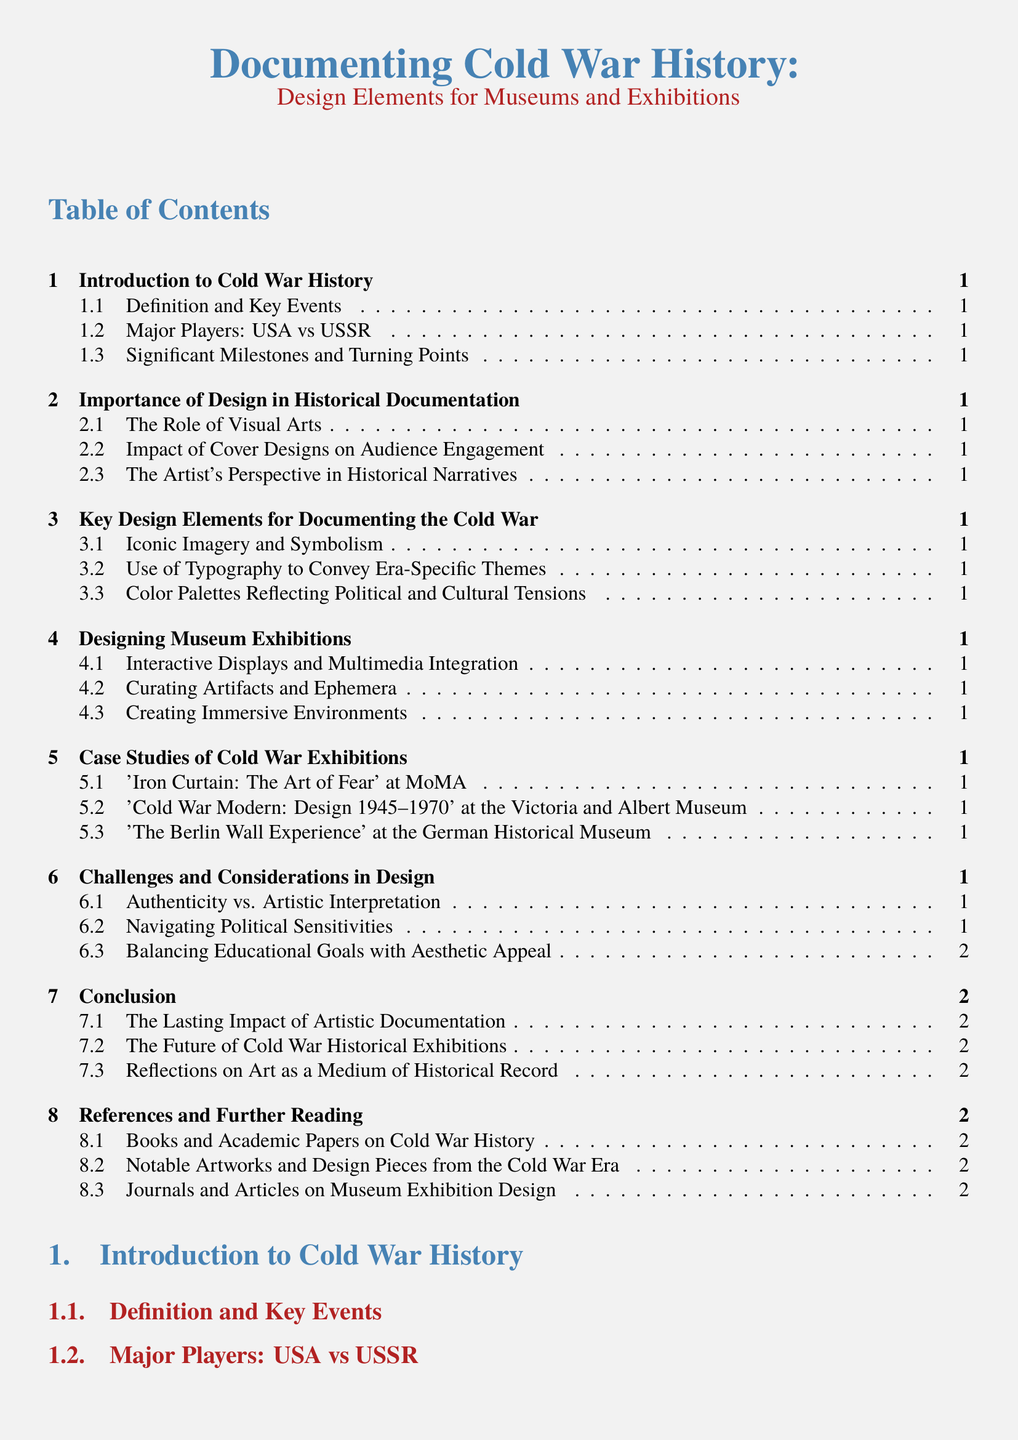What is the title of the document? The title is presented at the beginning of the document, highlighting the focus on Cold War history and design elements for museums and exhibitions.
Answer: Documenting Cold War History: Design Elements for Museums and Exhibitions How many sections are in the document? The total number of sections can be counted in the table of contents, listed under the main headings.
Answer: 7 What are the major players mentioned in Cold War history? The major players in the Cold War are specified in the section about key events and players.
Answer: USA vs USSR Which exhibition is listed first in the case studies section? The first exhibition is noted under case studies, showcasing a specific topic related to Cold War history.
Answer: 'Iron Curtain: The Art of Fear' at MoMA What design aspect is emphasized for audience engagement? The importance of this design element can be found in the section discussing the role of visual arts and their impact.
Answer: Cover Designs What color is associated with the section titles? The section titles are colored to enhance their visibility and thematic relevance throughout the document.
Answer: Cold War Blue What is the significance of authenticity in design? This concept is addressed in the challenges section, reflecting the balance required in artistic representation of history.
Answer: Authenticity vs. Artistic Interpretation 